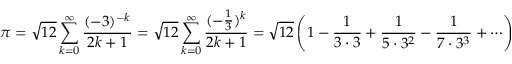<formula> <loc_0><loc_0><loc_500><loc_500>\pi = { \sqrt { 1 2 } } \sum _ { k = 0 } ^ { \infty } { \frac { ( - 3 ) ^ { - k } } { 2 k + 1 } } = { \sqrt { 1 2 } } \sum _ { k = 0 } ^ { \infty } { \frac { ( - { \frac { 1 } { 3 } } ) ^ { k } } { 2 k + 1 } } = { \sqrt { 1 2 } } \left ( 1 - { \frac { 1 } { 3 \cdot 3 } } + { \frac { 1 } { 5 \cdot 3 ^ { 2 } } } - { \frac { 1 } { 7 \cdot 3 ^ { 3 } } } + \cdots \right )</formula> 